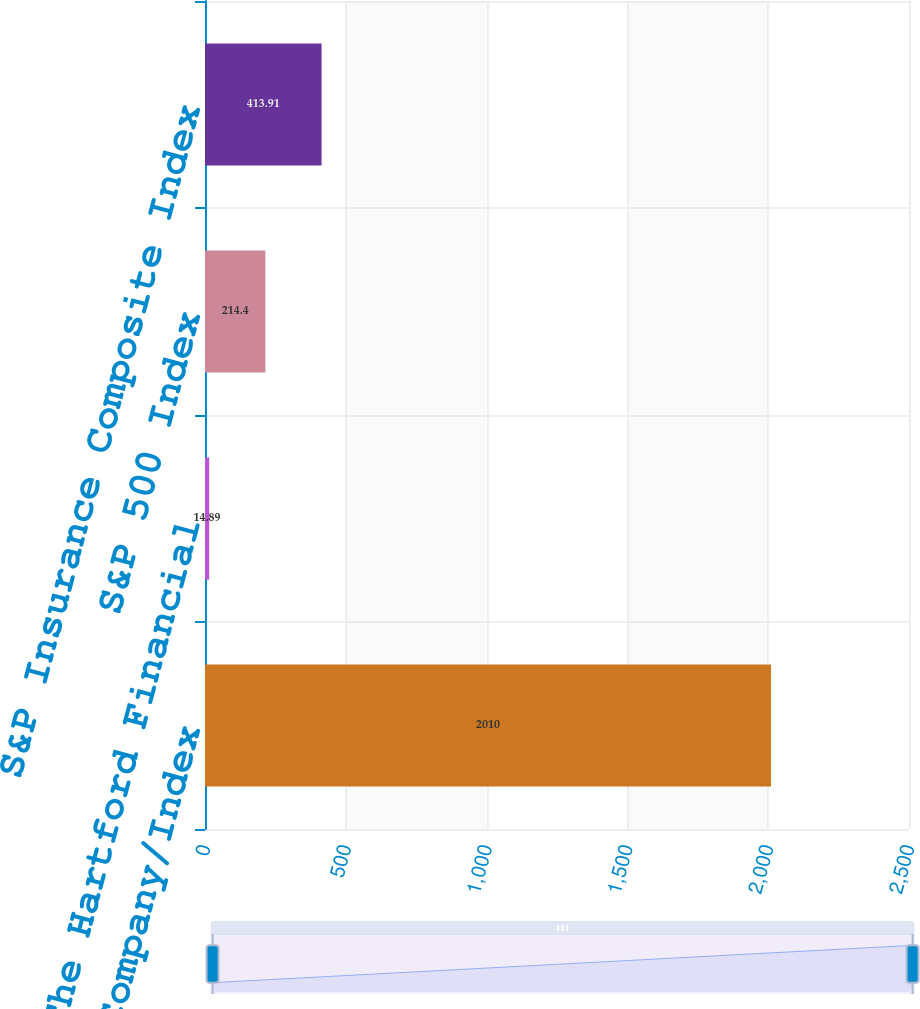Convert chart to OTSL. <chart><loc_0><loc_0><loc_500><loc_500><bar_chart><fcel>Company/Index<fcel>The Hartford Financial<fcel>S&P 500 Index<fcel>S&P Insurance Composite Index<nl><fcel>2010<fcel>14.89<fcel>214.4<fcel>413.91<nl></chart> 